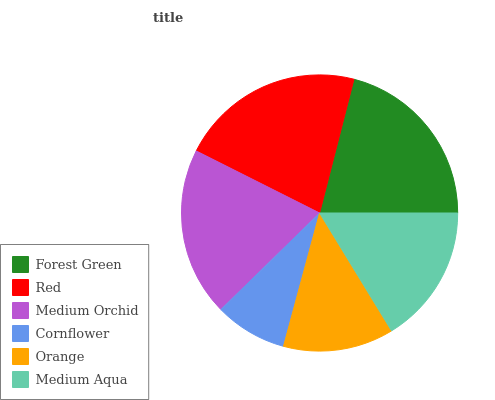Is Cornflower the minimum?
Answer yes or no. Yes. Is Red the maximum?
Answer yes or no. Yes. Is Medium Orchid the minimum?
Answer yes or no. No. Is Medium Orchid the maximum?
Answer yes or no. No. Is Red greater than Medium Orchid?
Answer yes or no. Yes. Is Medium Orchid less than Red?
Answer yes or no. Yes. Is Medium Orchid greater than Red?
Answer yes or no. No. Is Red less than Medium Orchid?
Answer yes or no. No. Is Medium Orchid the high median?
Answer yes or no. Yes. Is Medium Aqua the low median?
Answer yes or no. Yes. Is Medium Aqua the high median?
Answer yes or no. No. Is Orange the low median?
Answer yes or no. No. 